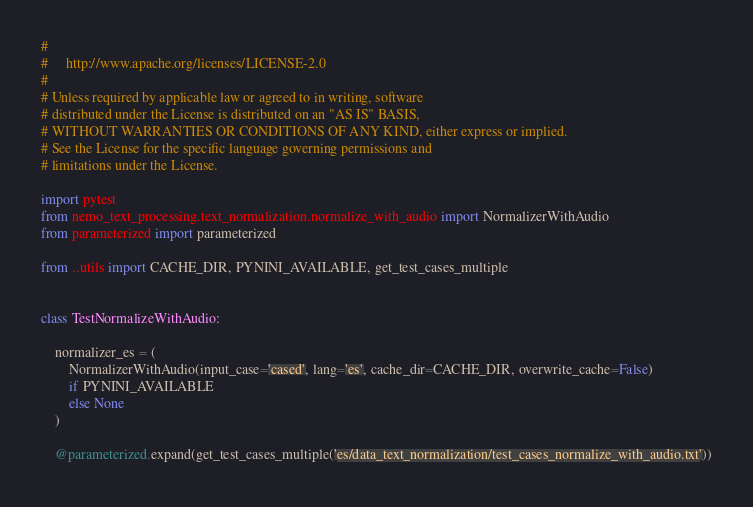Convert code to text. <code><loc_0><loc_0><loc_500><loc_500><_Python_>#
#     http://www.apache.org/licenses/LICENSE-2.0
#
# Unless required by applicable law or agreed to in writing, software
# distributed under the License is distributed on an "AS IS" BASIS,
# WITHOUT WARRANTIES OR CONDITIONS OF ANY KIND, either express or implied.
# See the License for the specific language governing permissions and
# limitations under the License.

import pytest
from nemo_text_processing.text_normalization.normalize_with_audio import NormalizerWithAudio
from parameterized import parameterized

from ..utils import CACHE_DIR, PYNINI_AVAILABLE, get_test_cases_multiple


class TestNormalizeWithAudio:

    normalizer_es = (
        NormalizerWithAudio(input_case='cased', lang='es', cache_dir=CACHE_DIR, overwrite_cache=False)
        if PYNINI_AVAILABLE
        else None
    )

    @parameterized.expand(get_test_cases_multiple('es/data_text_normalization/test_cases_normalize_with_audio.txt'))</code> 